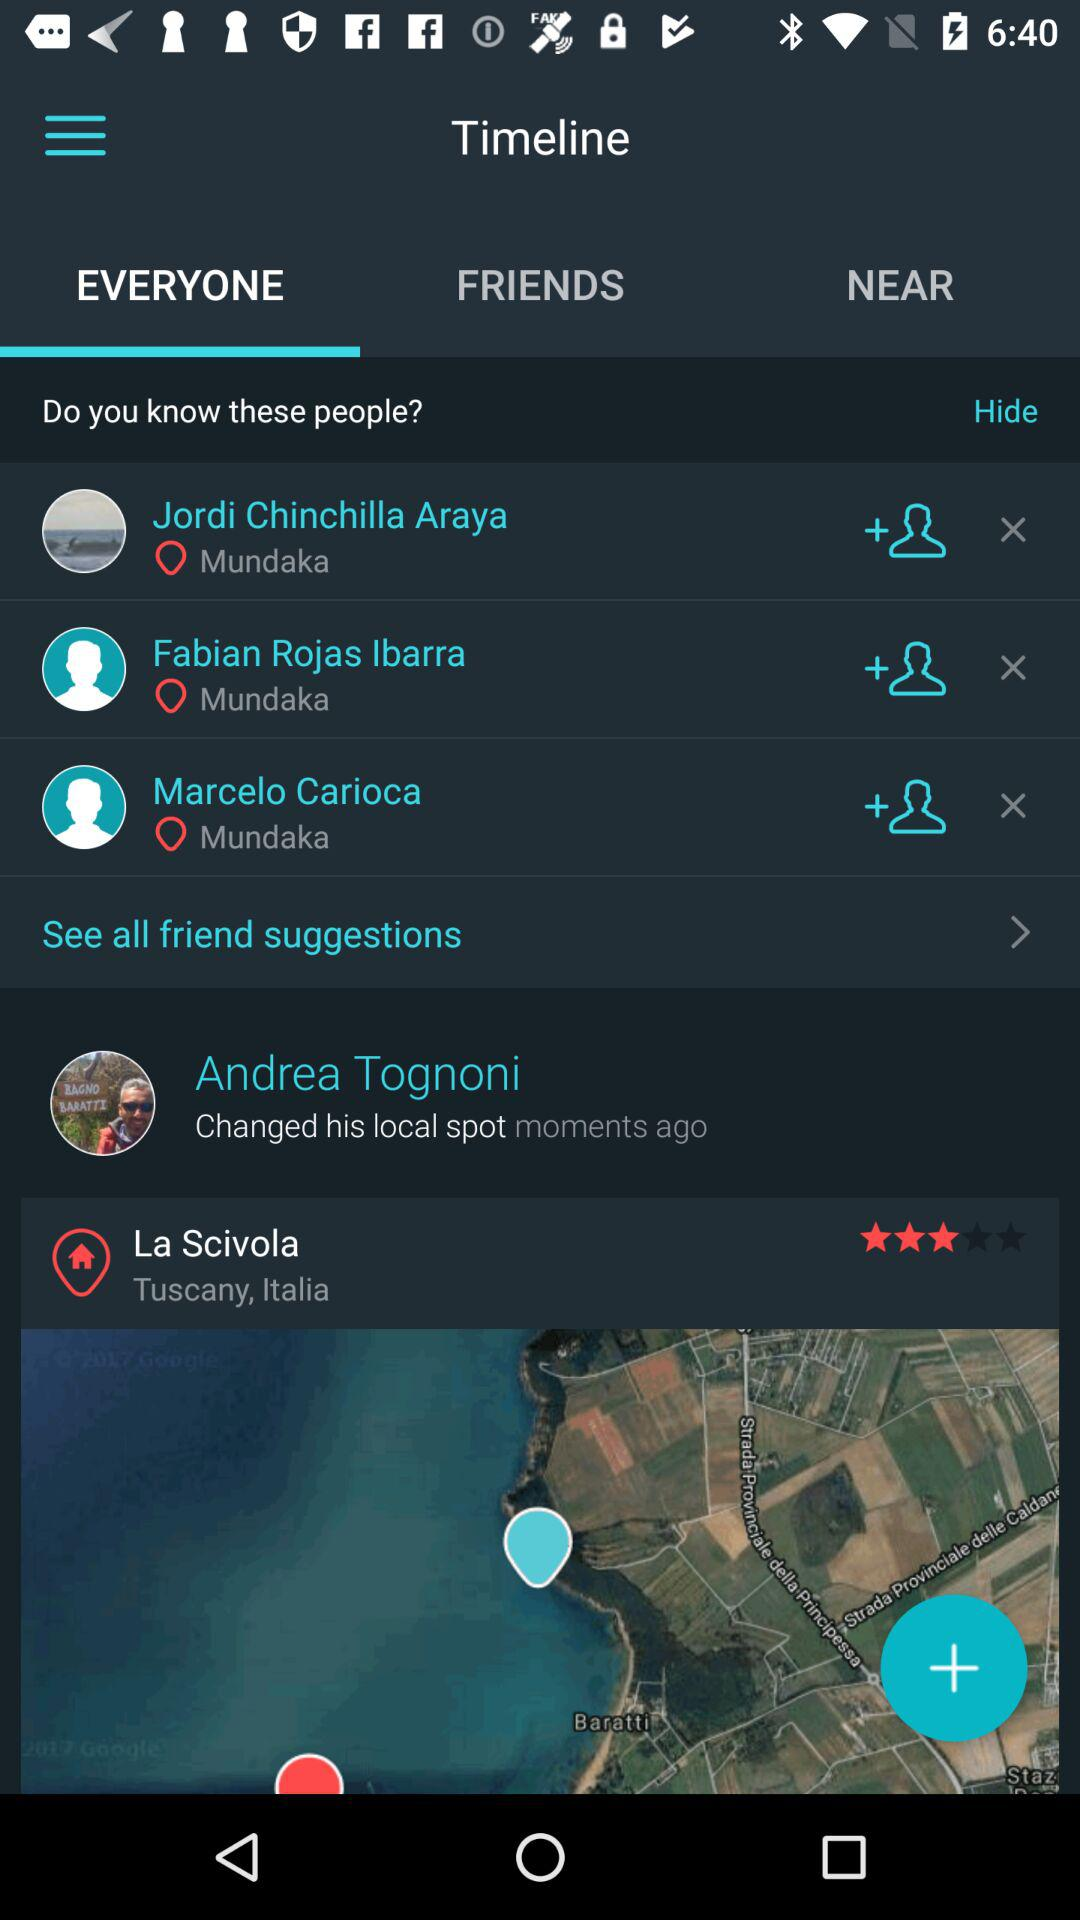How many friend suggestions are there?
Answer the question using a single word or phrase. 3 